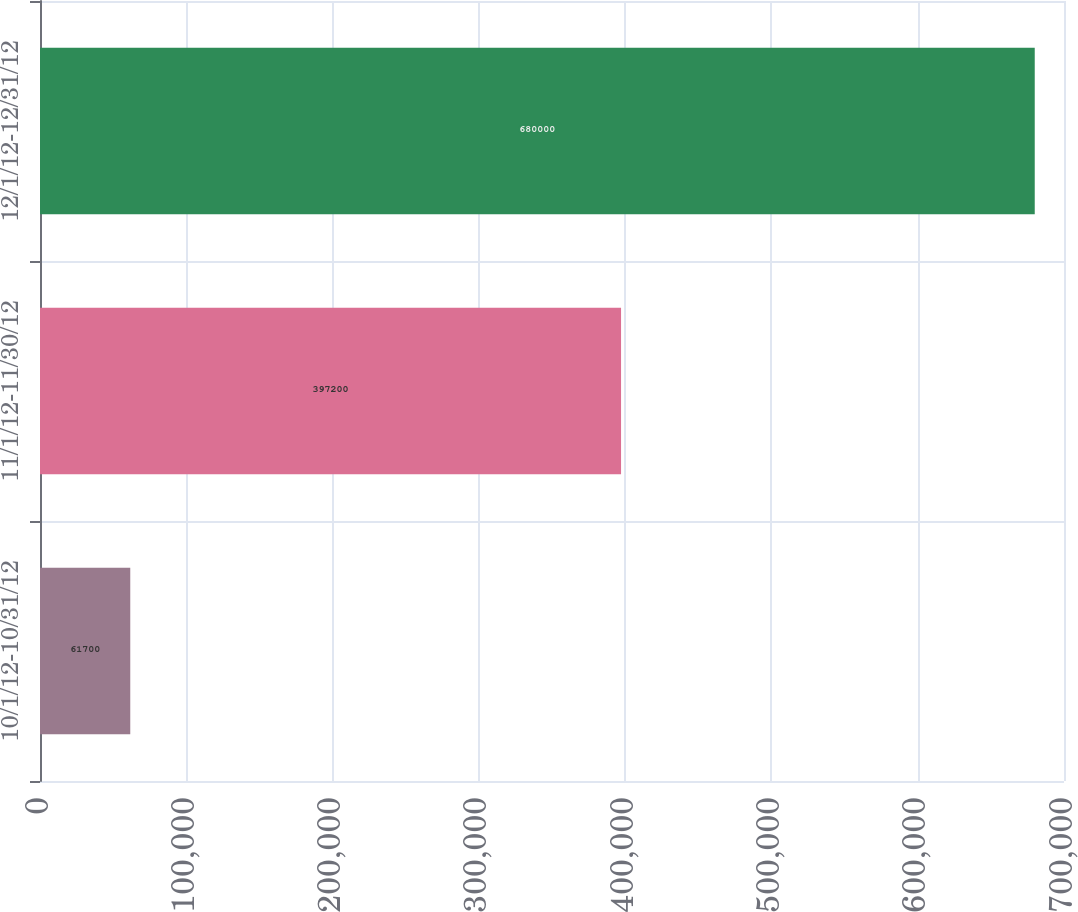Convert chart. <chart><loc_0><loc_0><loc_500><loc_500><bar_chart><fcel>10/1/12-10/31/12<fcel>11/1/12-11/30/12<fcel>12/1/12-12/31/12<nl><fcel>61700<fcel>397200<fcel>680000<nl></chart> 